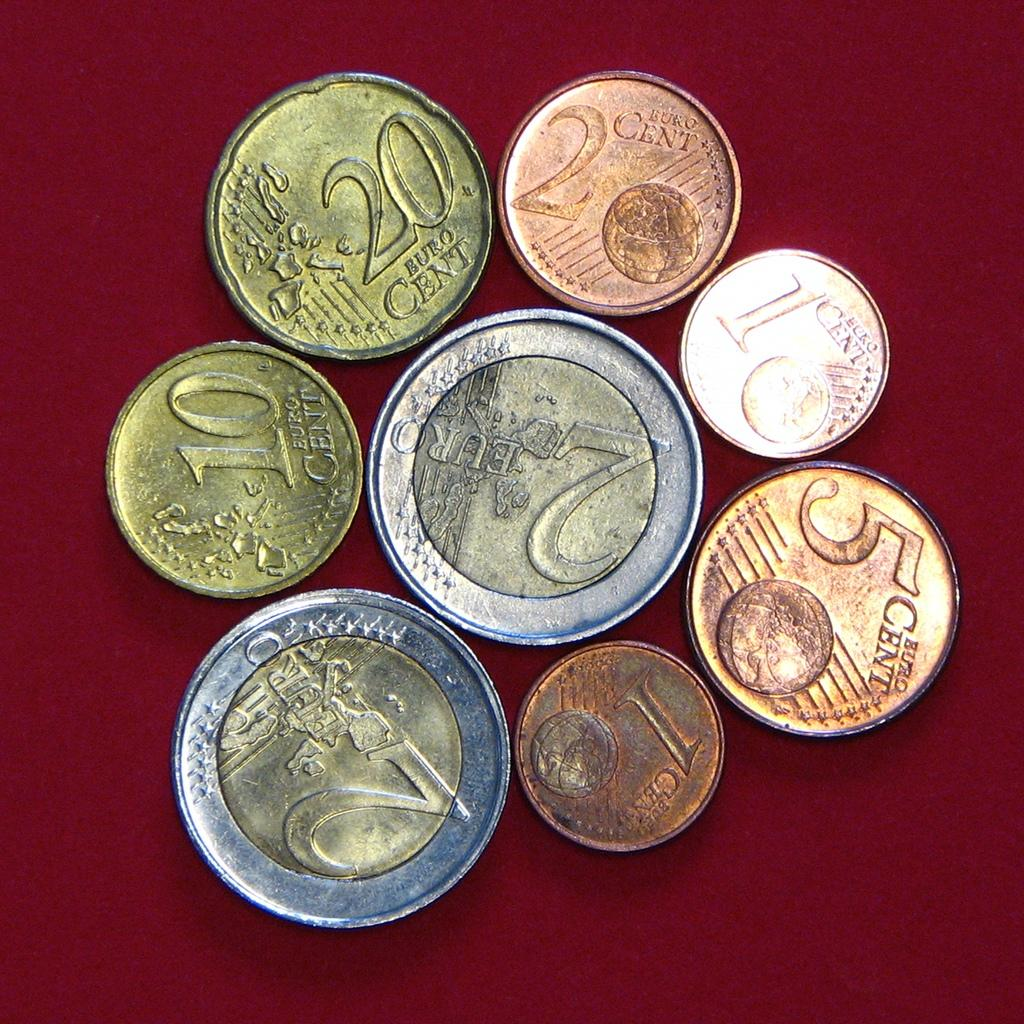<image>
Give a short and clear explanation of the subsequent image. Several coins are displayed including a copper 5 cent euro, a gold 20 cent euro, and a silver and gold 2 Euro. 